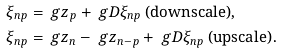Convert formula to latex. <formula><loc_0><loc_0><loc_500><loc_500>\xi _ { n p } & = \ g z _ { p } + \ g D \xi _ { n p } \text { (downscale)} , \\ \xi _ { n p } & = \ g z _ { n } - \ g z _ { n - p } + \ g D \xi _ { n p } \text { (upscale)} .</formula> 